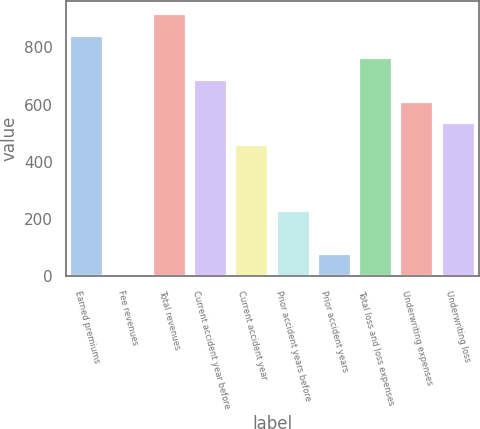Convert chart. <chart><loc_0><loc_0><loc_500><loc_500><bar_chart><fcel>Earned premiums<fcel>Fee revenues<fcel>Total revenues<fcel>Current accident year before<fcel>Current accident year<fcel>Prior accident years before<fcel>Prior accident years<fcel>Total loss and loss expenses<fcel>Underwriting expenses<fcel>Underwriting loss<nl><fcel>839.2<fcel>1<fcel>915.4<fcel>686.8<fcel>458.2<fcel>229.6<fcel>77.2<fcel>763<fcel>610.6<fcel>534.4<nl></chart> 